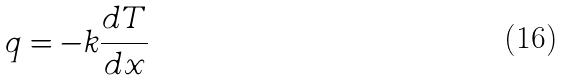Convert formula to latex. <formula><loc_0><loc_0><loc_500><loc_500>q = - k \frac { d T } { d x }</formula> 